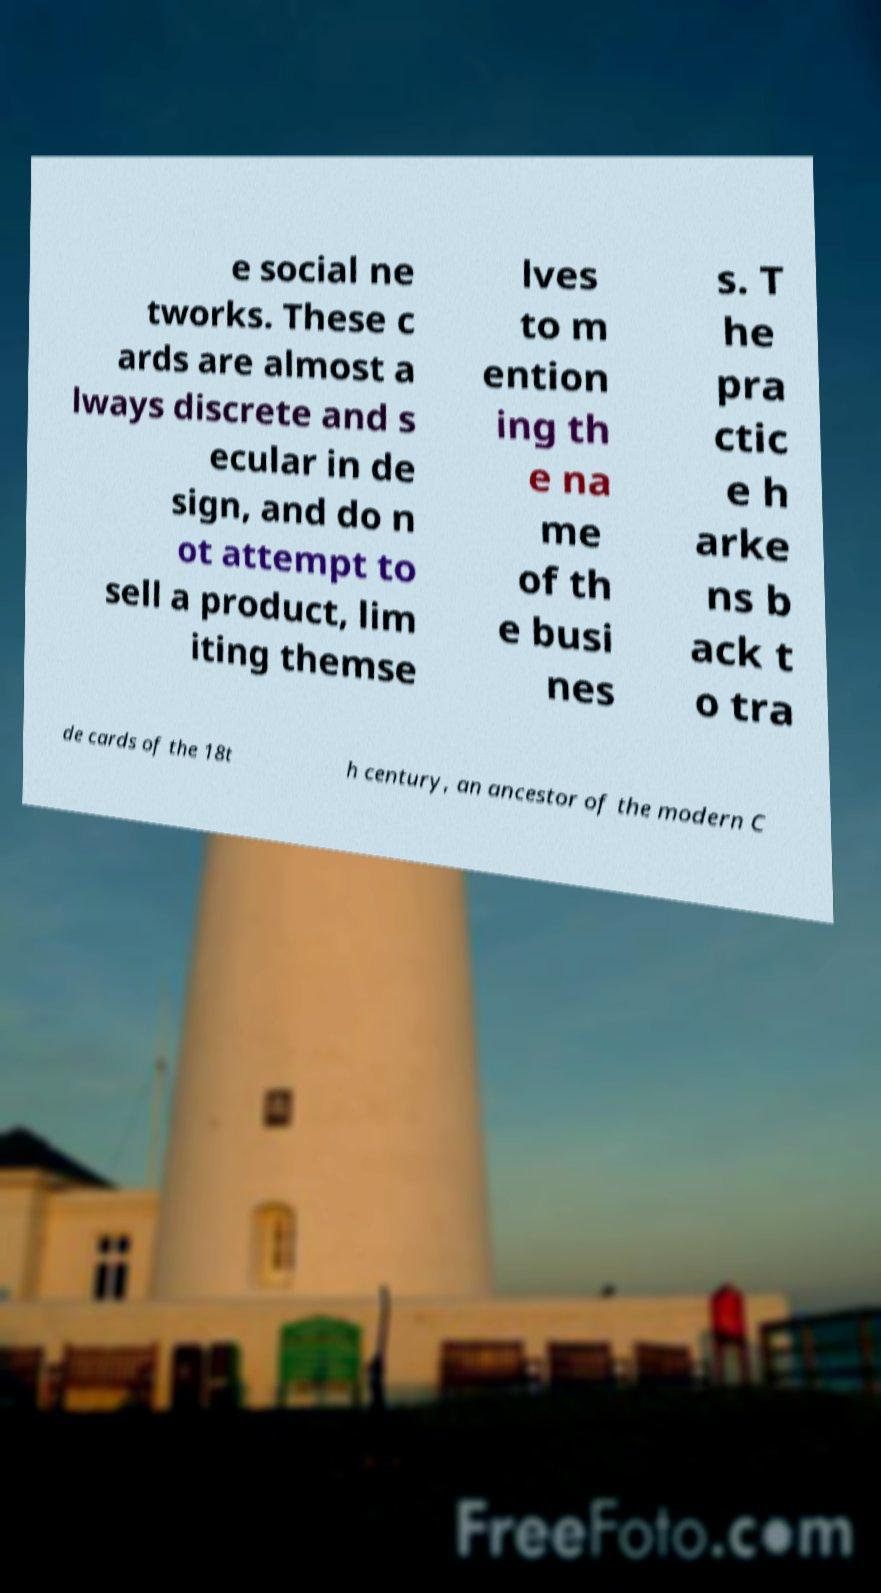Please read and relay the text visible in this image. What does it say? e social ne tworks. These c ards are almost a lways discrete and s ecular in de sign, and do n ot attempt to sell a product, lim iting themse lves to m ention ing th e na me of th e busi nes s. T he pra ctic e h arke ns b ack t o tra de cards of the 18t h century, an ancestor of the modern C 